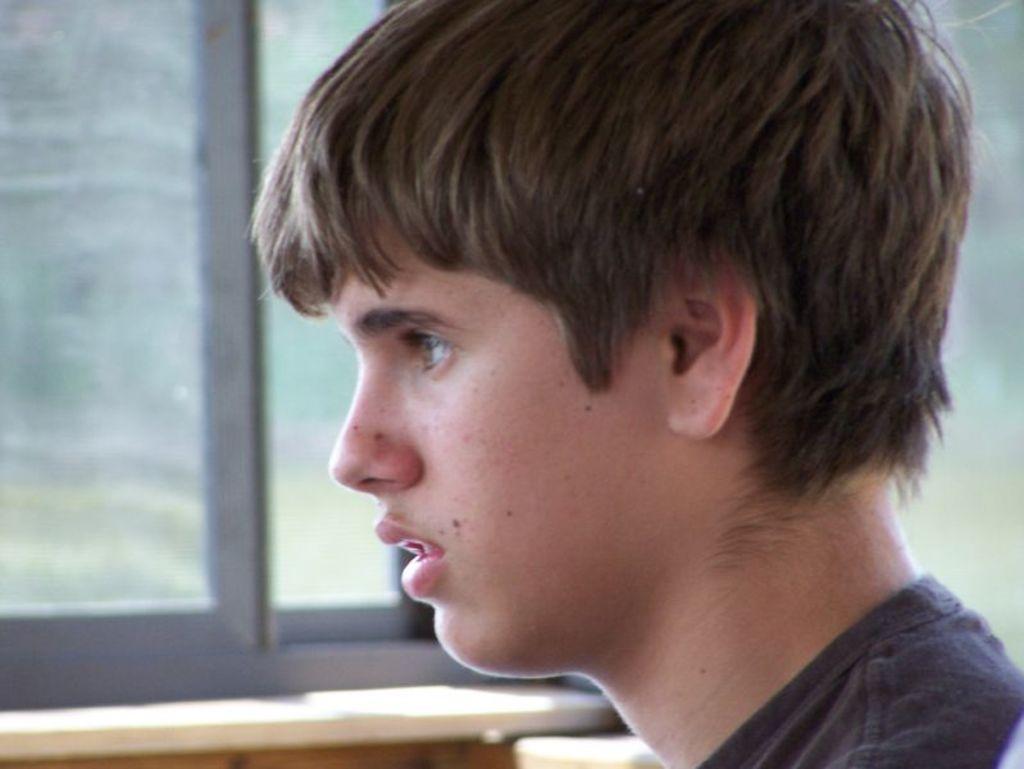How would you summarize this image in a sentence or two? In this image we can see a person and in the background there is a window. 